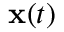Convert formula to latex. <formula><loc_0><loc_0><loc_500><loc_500>x ( t )</formula> 